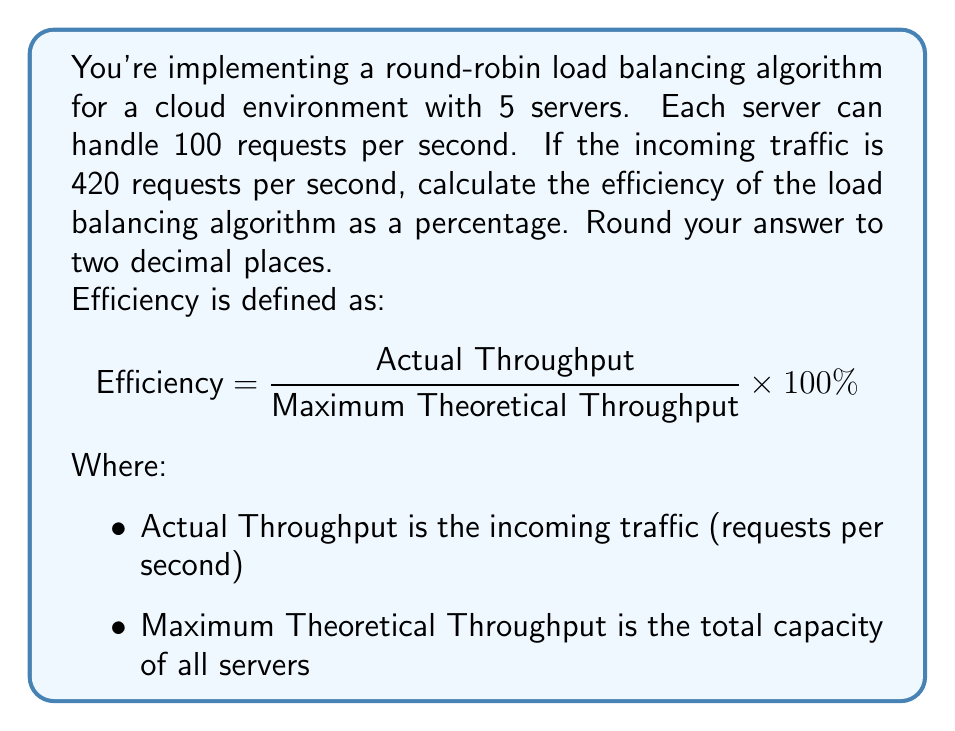Can you answer this question? Let's approach this step-by-step with a cloud consultant's mindset:

1) First, let's calculate the Maximum Theoretical Throughput:
   - We have 5 servers, each handling 100 requests per second
   $$ \text{Max Throughput} = 5 \times 100 = 500 \text{ requests/second} $$

2) The Actual Throughput is given as 420 requests per second

3) Now, let's plug these values into our efficiency formula:

   $$ \text{Efficiency} = \frac{\text{Actual Throughput}}{\text{Maximum Theoretical Throughput}} \times 100\% $$
   
   $$ = \frac{420}{500} \times 100\% $$

4) Let's calculate this:
   $$ = 0.84 \times 100\% = 84\% $$

5) Rounding to two decimal places:
   $$ 84.00\% $$

This means our load balancer is utilizing 84.00% of the available server capacity. Not too shabby for a bunch of virtual machines juggling requests like a cloud circus!
Answer: 84.00% 